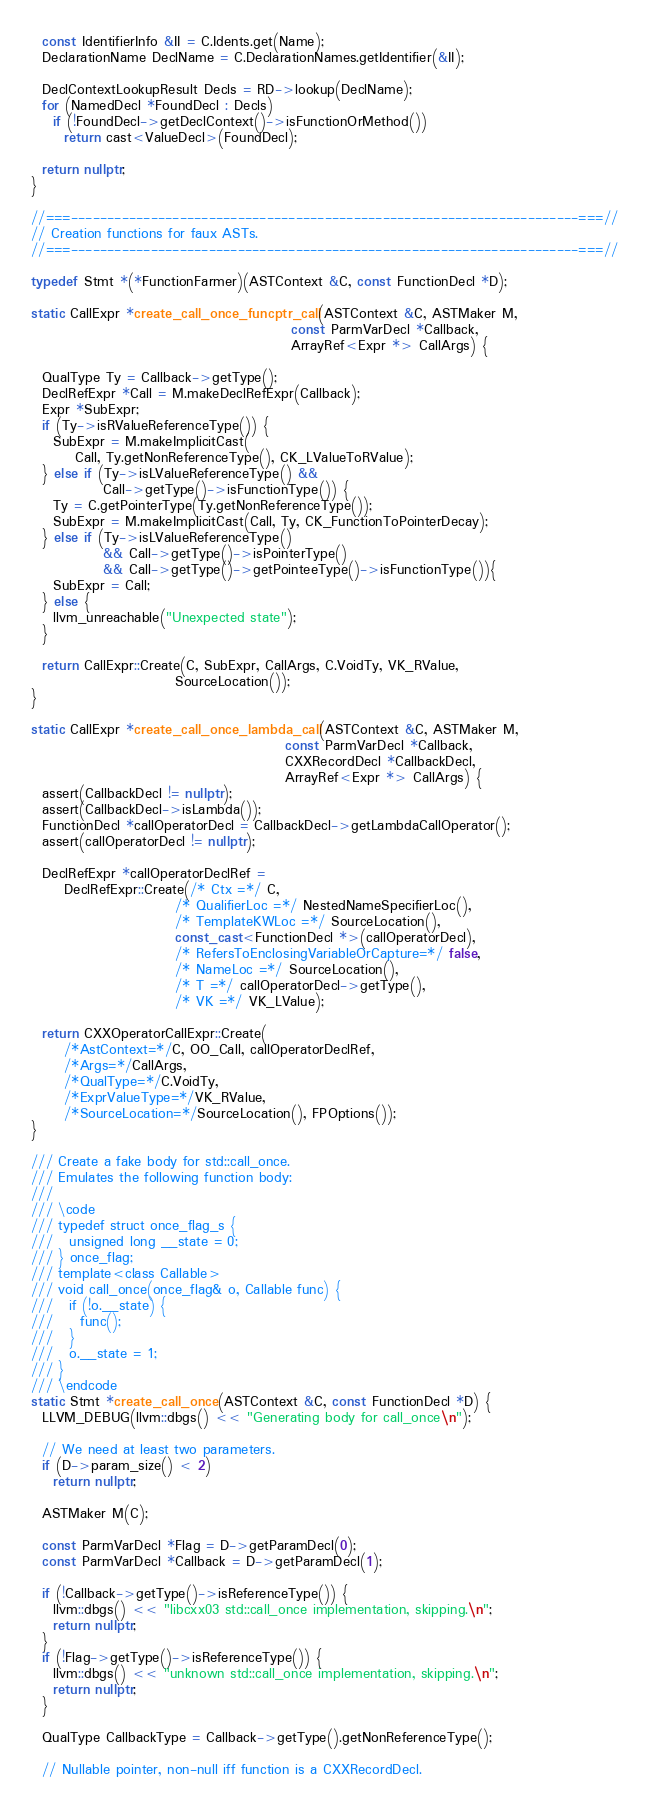Convert code to text. <code><loc_0><loc_0><loc_500><loc_500><_C++_>  const IdentifierInfo &II = C.Idents.get(Name);
  DeclarationName DeclName = C.DeclarationNames.getIdentifier(&II);

  DeclContextLookupResult Decls = RD->lookup(DeclName);
  for (NamedDecl *FoundDecl : Decls)
    if (!FoundDecl->getDeclContext()->isFunctionOrMethod())
      return cast<ValueDecl>(FoundDecl);

  return nullptr;
}

//===----------------------------------------------------------------------===//
// Creation functions for faux ASTs.
//===----------------------------------------------------------------------===//

typedef Stmt *(*FunctionFarmer)(ASTContext &C, const FunctionDecl *D);

static CallExpr *create_call_once_funcptr_call(ASTContext &C, ASTMaker M,
                                               const ParmVarDecl *Callback,
                                               ArrayRef<Expr *> CallArgs) {

  QualType Ty = Callback->getType();
  DeclRefExpr *Call = M.makeDeclRefExpr(Callback);
  Expr *SubExpr;
  if (Ty->isRValueReferenceType()) {
    SubExpr = M.makeImplicitCast(
        Call, Ty.getNonReferenceType(), CK_LValueToRValue);
  } else if (Ty->isLValueReferenceType() &&
             Call->getType()->isFunctionType()) {
    Ty = C.getPointerType(Ty.getNonReferenceType());
    SubExpr = M.makeImplicitCast(Call, Ty, CK_FunctionToPointerDecay);
  } else if (Ty->isLValueReferenceType()
             && Call->getType()->isPointerType()
             && Call->getType()->getPointeeType()->isFunctionType()){
    SubExpr = Call;
  } else {
    llvm_unreachable("Unexpected state");
  }

  return CallExpr::Create(C, SubExpr, CallArgs, C.VoidTy, VK_RValue,
                          SourceLocation());
}

static CallExpr *create_call_once_lambda_call(ASTContext &C, ASTMaker M,
                                              const ParmVarDecl *Callback,
                                              CXXRecordDecl *CallbackDecl,
                                              ArrayRef<Expr *> CallArgs) {
  assert(CallbackDecl != nullptr);
  assert(CallbackDecl->isLambda());
  FunctionDecl *callOperatorDecl = CallbackDecl->getLambdaCallOperator();
  assert(callOperatorDecl != nullptr);

  DeclRefExpr *callOperatorDeclRef =
      DeclRefExpr::Create(/* Ctx =*/ C,
                          /* QualifierLoc =*/ NestedNameSpecifierLoc(),
                          /* TemplateKWLoc =*/ SourceLocation(),
                          const_cast<FunctionDecl *>(callOperatorDecl),
                          /* RefersToEnclosingVariableOrCapture=*/ false,
                          /* NameLoc =*/ SourceLocation(),
                          /* T =*/ callOperatorDecl->getType(),
                          /* VK =*/ VK_LValue);

  return CXXOperatorCallExpr::Create(
      /*AstContext=*/C, OO_Call, callOperatorDeclRef,
      /*Args=*/CallArgs,
      /*QualType=*/C.VoidTy,
      /*ExprValueType=*/VK_RValue,
      /*SourceLocation=*/SourceLocation(), FPOptions());
}

/// Create a fake body for std::call_once.
/// Emulates the following function body:
///
/// \code
/// typedef struct once_flag_s {
///   unsigned long __state = 0;
/// } once_flag;
/// template<class Callable>
/// void call_once(once_flag& o, Callable func) {
///   if (!o.__state) {
///     func();
///   }
///   o.__state = 1;
/// }
/// \endcode
static Stmt *create_call_once(ASTContext &C, const FunctionDecl *D) {
  LLVM_DEBUG(llvm::dbgs() << "Generating body for call_once\n");

  // We need at least two parameters.
  if (D->param_size() < 2)
    return nullptr;

  ASTMaker M(C);

  const ParmVarDecl *Flag = D->getParamDecl(0);
  const ParmVarDecl *Callback = D->getParamDecl(1);

  if (!Callback->getType()->isReferenceType()) {
    llvm::dbgs() << "libcxx03 std::call_once implementation, skipping.\n";
    return nullptr;
  }
  if (!Flag->getType()->isReferenceType()) {
    llvm::dbgs() << "unknown std::call_once implementation, skipping.\n";
    return nullptr;
  }

  QualType CallbackType = Callback->getType().getNonReferenceType();

  // Nullable pointer, non-null iff function is a CXXRecordDecl.</code> 